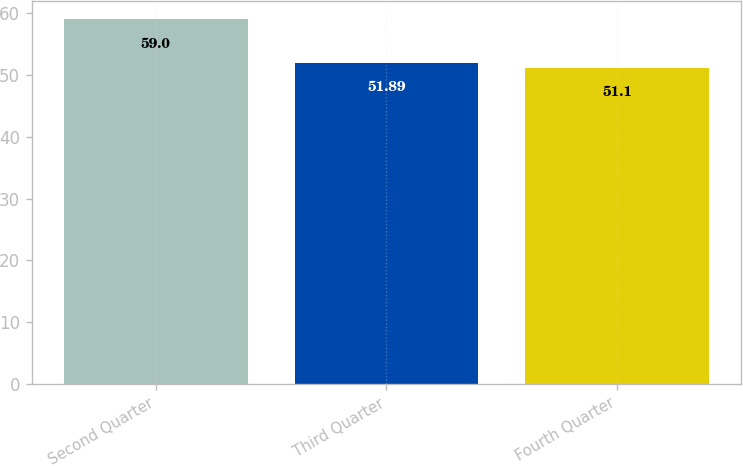Convert chart. <chart><loc_0><loc_0><loc_500><loc_500><bar_chart><fcel>Second Quarter<fcel>Third Quarter<fcel>Fourth Quarter<nl><fcel>59<fcel>51.89<fcel>51.1<nl></chart> 